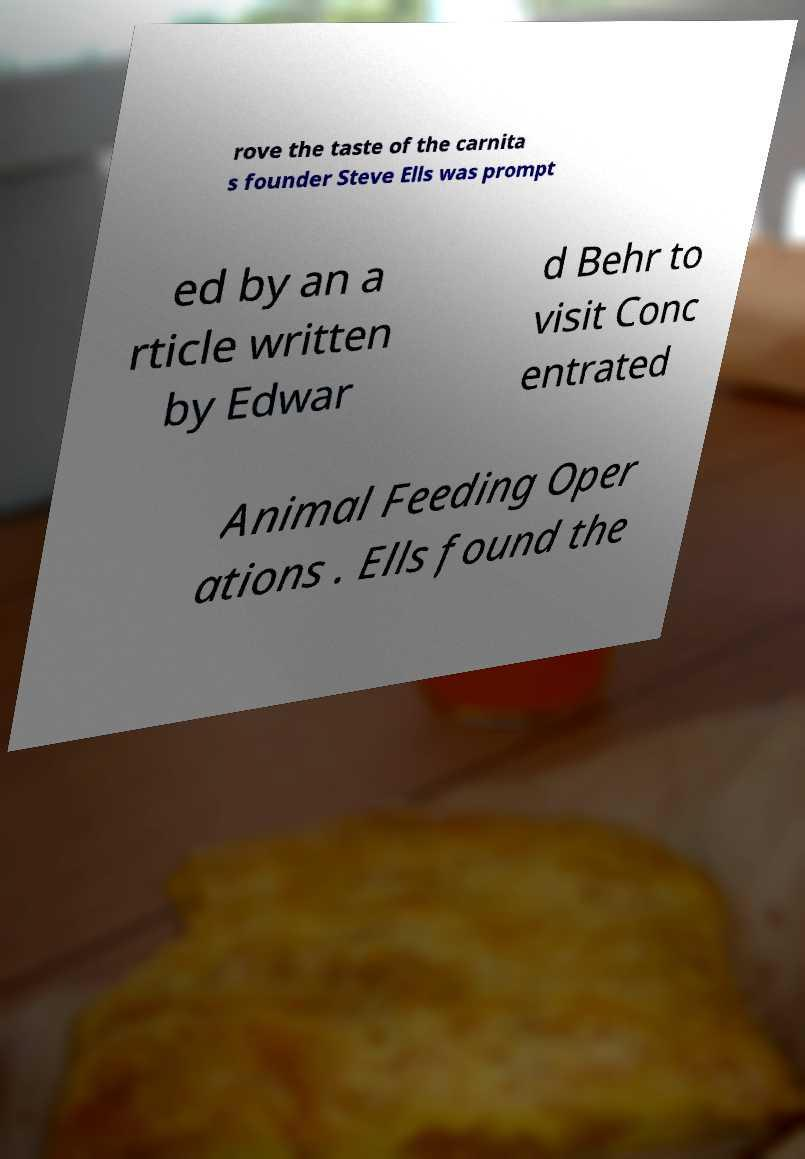Could you extract and type out the text from this image? rove the taste of the carnita s founder Steve Ells was prompt ed by an a rticle written by Edwar d Behr to visit Conc entrated Animal Feeding Oper ations . Ells found the 